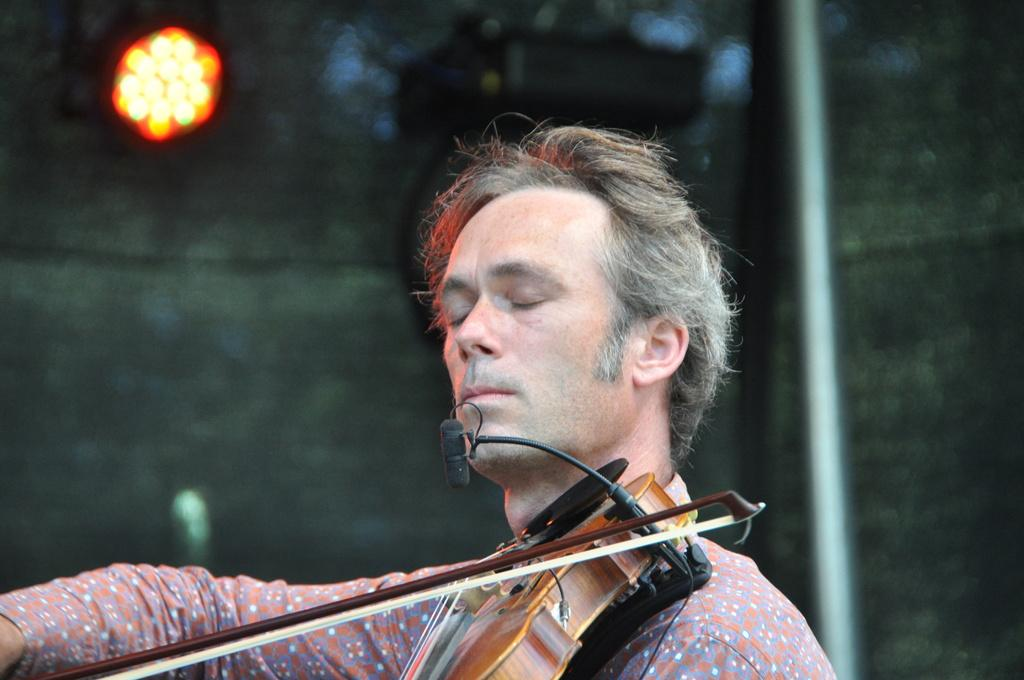What is the main activity being performed by the person in the image? The person is playing a violin in the image. Where is the person located in the image? The person is at the bottom of the image. What object can be seen on the right side of the image? There is a rod on the right side of the image. What is the source of light in the image? There is a light at the top of the image. What type of pickle is being used as a mute for the violin in the image? There is no pickle present in the image, nor is it being used as a mute for the violin. 